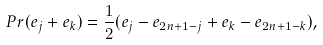Convert formula to latex. <formula><loc_0><loc_0><loc_500><loc_500>P r ( e _ { j } + e _ { k } ) = \frac { 1 } { 2 } ( e _ { j } - e _ { 2 n + 1 - j } + e _ { k } - e _ { 2 n + 1 - k } ) ,</formula> 